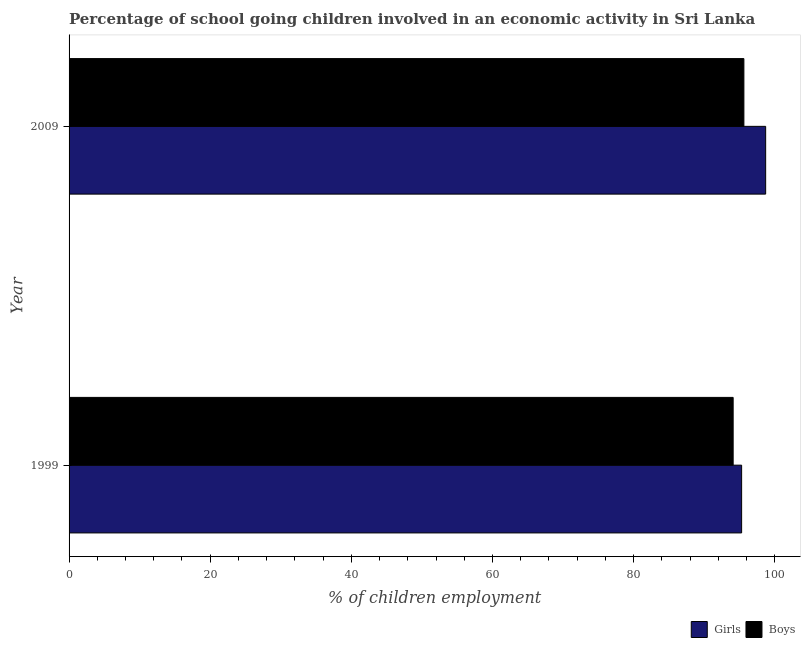How many bars are there on the 1st tick from the top?
Offer a terse response. 2. What is the percentage of school going girls in 1999?
Keep it short and to the point. 95.3. Across all years, what is the maximum percentage of school going girls?
Offer a terse response. 98.71. Across all years, what is the minimum percentage of school going girls?
Your answer should be very brief. 95.3. In which year was the percentage of school going girls maximum?
Make the answer very short. 2009. What is the total percentage of school going girls in the graph?
Offer a terse response. 194.01. What is the difference between the percentage of school going boys in 1999 and that in 2009?
Your response must be concise. -1.52. What is the difference between the percentage of school going boys in 2009 and the percentage of school going girls in 1999?
Offer a terse response. 0.32. What is the average percentage of school going boys per year?
Keep it short and to the point. 94.86. In the year 1999, what is the difference between the percentage of school going boys and percentage of school going girls?
Offer a very short reply. -1.2. What is the ratio of the percentage of school going girls in 1999 to that in 2009?
Offer a very short reply. 0.97. What does the 1st bar from the top in 2009 represents?
Make the answer very short. Boys. What does the 1st bar from the bottom in 2009 represents?
Your answer should be compact. Girls. How many bars are there?
Offer a very short reply. 4. Are all the bars in the graph horizontal?
Provide a short and direct response. Yes. How many years are there in the graph?
Make the answer very short. 2. Are the values on the major ticks of X-axis written in scientific E-notation?
Keep it short and to the point. No. Does the graph contain any zero values?
Your answer should be compact. No. Does the graph contain grids?
Your answer should be compact. No. What is the title of the graph?
Offer a very short reply. Percentage of school going children involved in an economic activity in Sri Lanka. Does "Non-pregnant women" appear as one of the legend labels in the graph?
Provide a short and direct response. No. What is the label or title of the X-axis?
Keep it short and to the point. % of children employment. What is the label or title of the Y-axis?
Provide a succinct answer. Year. What is the % of children employment in Girls in 1999?
Offer a very short reply. 95.3. What is the % of children employment in Boys in 1999?
Offer a terse response. 94.1. What is the % of children employment of Girls in 2009?
Your answer should be very brief. 98.71. What is the % of children employment in Boys in 2009?
Offer a very short reply. 95.62. Across all years, what is the maximum % of children employment in Girls?
Offer a terse response. 98.71. Across all years, what is the maximum % of children employment of Boys?
Your response must be concise. 95.62. Across all years, what is the minimum % of children employment in Girls?
Provide a short and direct response. 95.3. Across all years, what is the minimum % of children employment of Boys?
Give a very brief answer. 94.1. What is the total % of children employment of Girls in the graph?
Offer a very short reply. 194. What is the total % of children employment of Boys in the graph?
Keep it short and to the point. 189.72. What is the difference between the % of children employment in Girls in 1999 and that in 2009?
Offer a very short reply. -3.4. What is the difference between the % of children employment in Boys in 1999 and that in 2009?
Provide a succinct answer. -1.52. What is the difference between the % of children employment in Girls in 1999 and the % of children employment in Boys in 2009?
Your answer should be very brief. -0.32. What is the average % of children employment of Girls per year?
Offer a very short reply. 97. What is the average % of children employment of Boys per year?
Offer a terse response. 94.86. In the year 1999, what is the difference between the % of children employment of Girls and % of children employment of Boys?
Your response must be concise. 1.2. In the year 2009, what is the difference between the % of children employment of Girls and % of children employment of Boys?
Your answer should be compact. 3.08. What is the ratio of the % of children employment in Girls in 1999 to that in 2009?
Ensure brevity in your answer.  0.97. What is the ratio of the % of children employment in Boys in 1999 to that in 2009?
Make the answer very short. 0.98. What is the difference between the highest and the second highest % of children employment of Girls?
Make the answer very short. 3.4. What is the difference between the highest and the second highest % of children employment in Boys?
Offer a very short reply. 1.52. What is the difference between the highest and the lowest % of children employment in Girls?
Offer a very short reply. 3.4. What is the difference between the highest and the lowest % of children employment in Boys?
Provide a succinct answer. 1.52. 